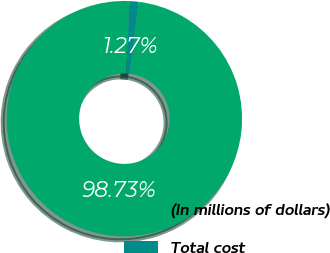<chart> <loc_0><loc_0><loc_500><loc_500><pie_chart><fcel>(In millions of dollars)<fcel>Total cost<nl><fcel>98.73%<fcel>1.27%<nl></chart> 